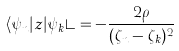<formula> <loc_0><loc_0><loc_500><loc_500>\langle \psi _ { n } | z | \psi _ { k } \rangle = - \frac { 2 \rho } { ( \zeta _ { n } - \zeta _ { k } ) ^ { 2 } }</formula> 